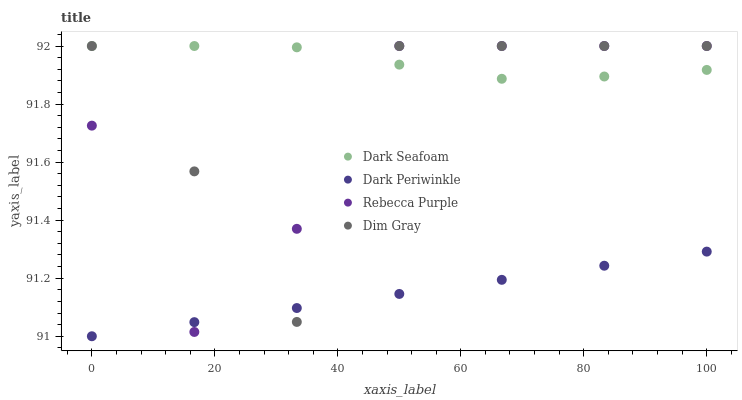Does Dark Periwinkle have the minimum area under the curve?
Answer yes or no. Yes. Does Dark Seafoam have the maximum area under the curve?
Answer yes or no. Yes. Does Dim Gray have the minimum area under the curve?
Answer yes or no. No. Does Dim Gray have the maximum area under the curve?
Answer yes or no. No. Is Dark Periwinkle the smoothest?
Answer yes or no. Yes. Is Dim Gray the roughest?
Answer yes or no. Yes. Is Dim Gray the smoothest?
Answer yes or no. No. Is Dark Periwinkle the roughest?
Answer yes or no. No. Does Dark Periwinkle have the lowest value?
Answer yes or no. Yes. Does Dim Gray have the lowest value?
Answer yes or no. No. Does Rebecca Purple have the highest value?
Answer yes or no. Yes. Does Dark Periwinkle have the highest value?
Answer yes or no. No. Is Dark Periwinkle less than Dark Seafoam?
Answer yes or no. Yes. Is Dark Seafoam greater than Dark Periwinkle?
Answer yes or no. Yes. Does Dark Periwinkle intersect Dim Gray?
Answer yes or no. Yes. Is Dark Periwinkle less than Dim Gray?
Answer yes or no. No. Is Dark Periwinkle greater than Dim Gray?
Answer yes or no. No. Does Dark Periwinkle intersect Dark Seafoam?
Answer yes or no. No. 